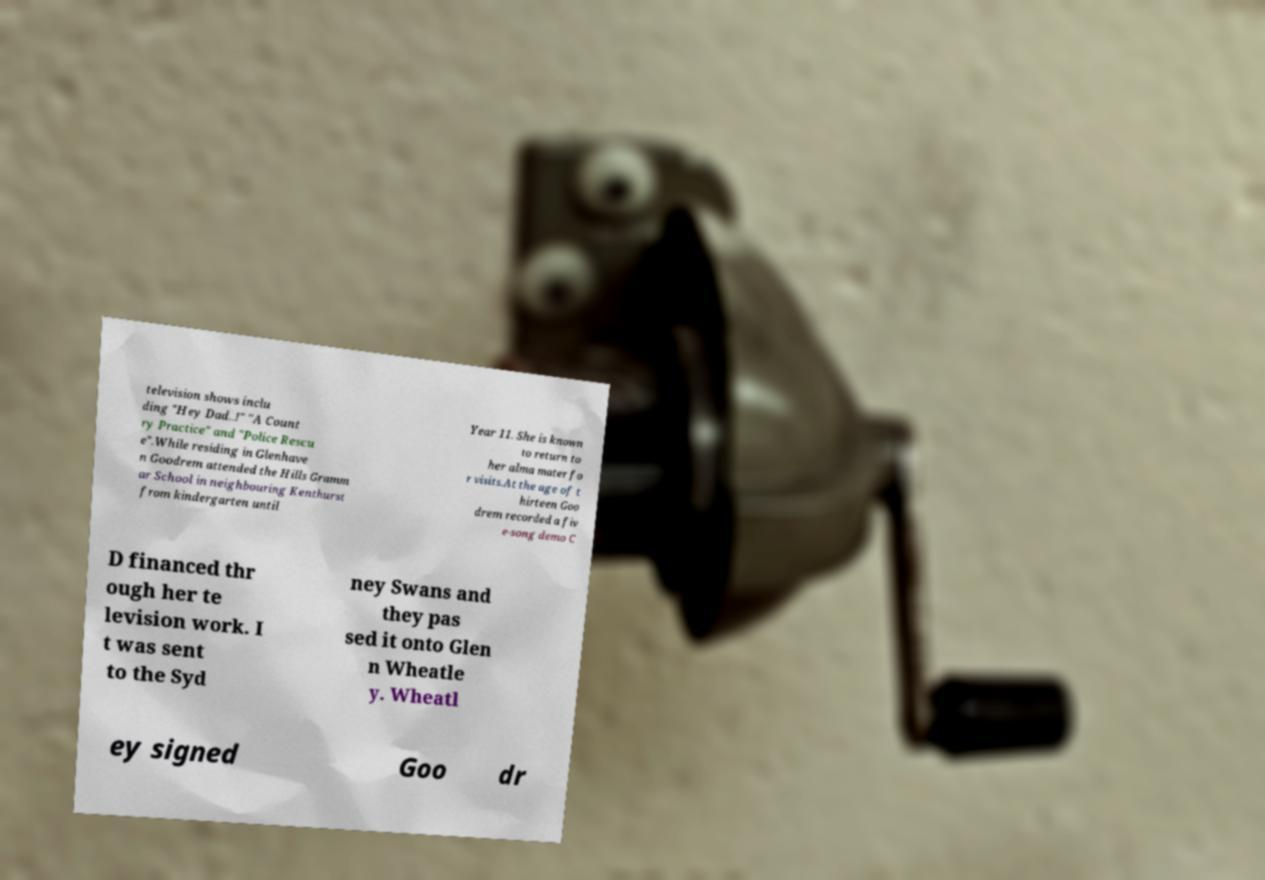Could you assist in decoding the text presented in this image and type it out clearly? television shows inclu ding "Hey Dad..!" "A Count ry Practice" and "Police Rescu e".While residing in Glenhave n Goodrem attended the Hills Gramm ar School in neighbouring Kenthurst from kindergarten until Year 11. She is known to return to her alma mater fo r visits.At the age of t hirteen Goo drem recorded a fiv e-song demo C D financed thr ough her te levision work. I t was sent to the Syd ney Swans and they pas sed it onto Glen n Wheatle y. Wheatl ey signed Goo dr 